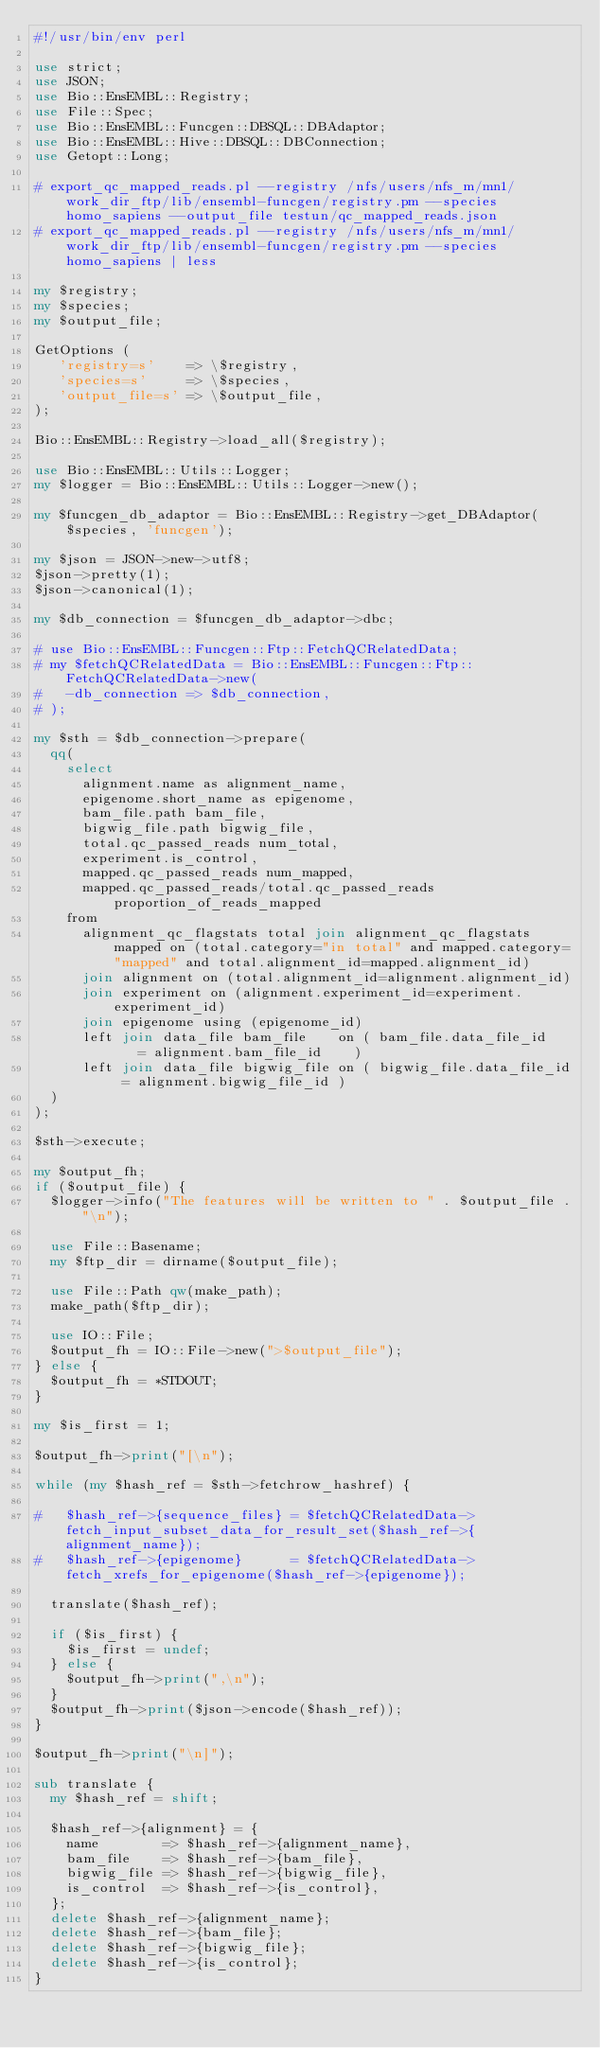Convert code to text. <code><loc_0><loc_0><loc_500><loc_500><_Perl_>#!/usr/bin/env perl

use strict;
use JSON;
use Bio::EnsEMBL::Registry;
use File::Spec;
use Bio::EnsEMBL::Funcgen::DBSQL::DBAdaptor;
use Bio::EnsEMBL::Hive::DBSQL::DBConnection;
use Getopt::Long;

# export_qc_mapped_reads.pl --registry /nfs/users/nfs_m/mn1/work_dir_ftp/lib/ensembl-funcgen/registry.pm --species homo_sapiens --output_file testun/qc_mapped_reads.json 
# export_qc_mapped_reads.pl --registry /nfs/users/nfs_m/mn1/work_dir_ftp/lib/ensembl-funcgen/registry.pm --species homo_sapiens | less

my $registry;
my $species;
my $output_file;

GetOptions (
   'registry=s'    => \$registry,
   'species=s'     => \$species,
   'output_file=s' => \$output_file,
);

Bio::EnsEMBL::Registry->load_all($registry);

use Bio::EnsEMBL::Utils::Logger;
my $logger = Bio::EnsEMBL::Utils::Logger->new();

my $funcgen_db_adaptor = Bio::EnsEMBL::Registry->get_DBAdaptor($species, 'funcgen');

my $json = JSON->new->utf8;
$json->pretty(1);
$json->canonical(1);

my $db_connection = $funcgen_db_adaptor->dbc;

# use Bio::EnsEMBL::Funcgen::Ftp::FetchQCRelatedData;
# my $fetchQCRelatedData = Bio::EnsEMBL::Funcgen::Ftp::FetchQCRelatedData->new(
#   -db_connection => $db_connection,
# );

my $sth = $db_connection->prepare(
  qq(
    select 
      alignment.name as alignment_name,
      epigenome.short_name as epigenome,
      bam_file.path bam_file,
      bigwig_file.path bigwig_file,
      total.qc_passed_reads num_total, 
      experiment.is_control,
      mapped.qc_passed_reads num_mapped, 
      mapped.qc_passed_reads/total.qc_passed_reads proportion_of_reads_mapped
    from 
      alignment_qc_flagstats total join alignment_qc_flagstats mapped on (total.category="in total" and mapped.category="mapped" and total.alignment_id=mapped.alignment_id)
      join alignment on (total.alignment_id=alignment.alignment_id) 
      join experiment on (alignment.experiment_id=experiment.experiment_id)
      join epigenome using (epigenome_id)
      left join data_file bam_file    on ( bam_file.data_file_id    = alignment.bam_file_id    )
      left join data_file bigwig_file on ( bigwig_file.data_file_id = alignment.bigwig_file_id )
  )
);

$sth->execute;

my $output_fh;
if ($output_file) {
  $logger->info("The features will be written to " . $output_file ."\n");

  use File::Basename;
  my $ftp_dir = dirname($output_file);

  use File::Path qw(make_path);
  make_path($ftp_dir);

  use IO::File;
  $output_fh = IO::File->new(">$output_file");
} else {
  $output_fh = *STDOUT;
}

my $is_first = 1;

$output_fh->print("[\n");

while (my $hash_ref = $sth->fetchrow_hashref) {

#   $hash_ref->{sequence_files} = $fetchQCRelatedData->fetch_input_subset_data_for_result_set($hash_ref->{alignment_name});
#   $hash_ref->{epigenome}      = $fetchQCRelatedData->fetch_xrefs_for_epigenome($hash_ref->{epigenome});

  translate($hash_ref);

  if ($is_first) {
    $is_first = undef;
  } else {
    $output_fh->print(",\n");
  }
  $output_fh->print($json->encode($hash_ref));
}

$output_fh->print("\n]");

sub translate {
  my $hash_ref = shift;
  
  $hash_ref->{alignment} = {
    name        => $hash_ref->{alignment_name},
    bam_file    => $hash_ref->{bam_file},
    bigwig_file => $hash_ref->{bigwig_file},
    is_control  => $hash_ref->{is_control},
  };
  delete $hash_ref->{alignment_name};
  delete $hash_ref->{bam_file};
  delete $hash_ref->{bigwig_file};
  delete $hash_ref->{is_control};
}
</code> 